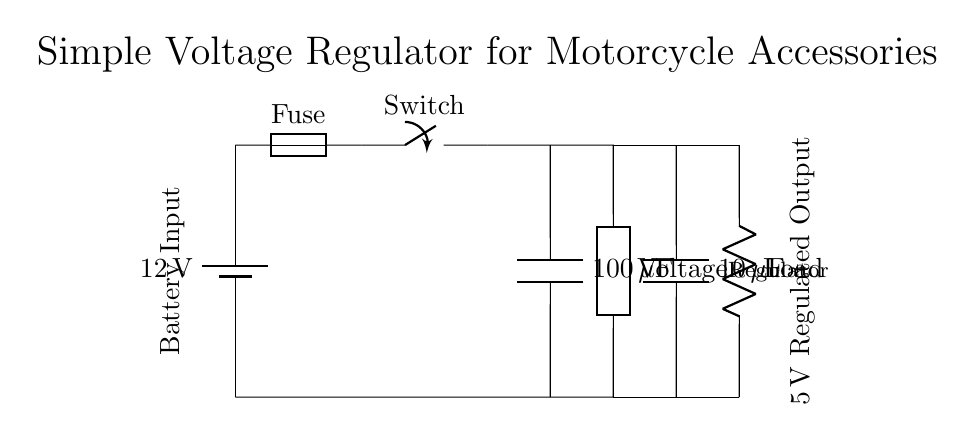What is the input voltage for this circuit? The input voltage is shown as 12V, which is labeled on the battery in the circuit diagram.
Answer: 12V What type of component is the voltage regulator? The voltage regulator is depicted as a generic component labeled as "Voltage Regulator" in the circuit.
Answer: Voltage Regulator What is the capacitance of the first capacitor? The first capacitor is labeled with a capacitance value of 100 microfarads, located above the voltage regulator in the diagram.
Answer: 100 microfarads How many capacitors are used in this voltage regulator circuit? There are two capacitors present in the circuit, each labeled at different positions, indicating their importance in stabilizing the output voltage.
Answer: Two What is the output voltage of this circuit? The output voltage is indicated as 5V, which is shown in the labeling next to the output connection on the circuit diagram.
Answer: 5V What load is present in the circuit? A resistor labeled as "Load" is present in the circuit, which represents the device receiving power from the regulator.
Answer: Resistor What is the purpose of the fuse in this circuit? The fuse serves as a safety component to prevent excess current from damaging the circuit or components, ensuring safe operation.
Answer: Safety 